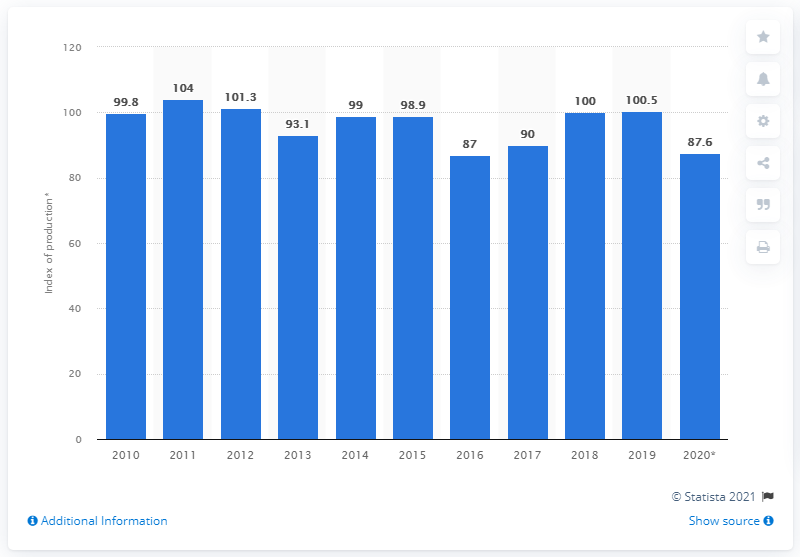Specify some key components in this picture. The production output index was 87.6 by 2020. 